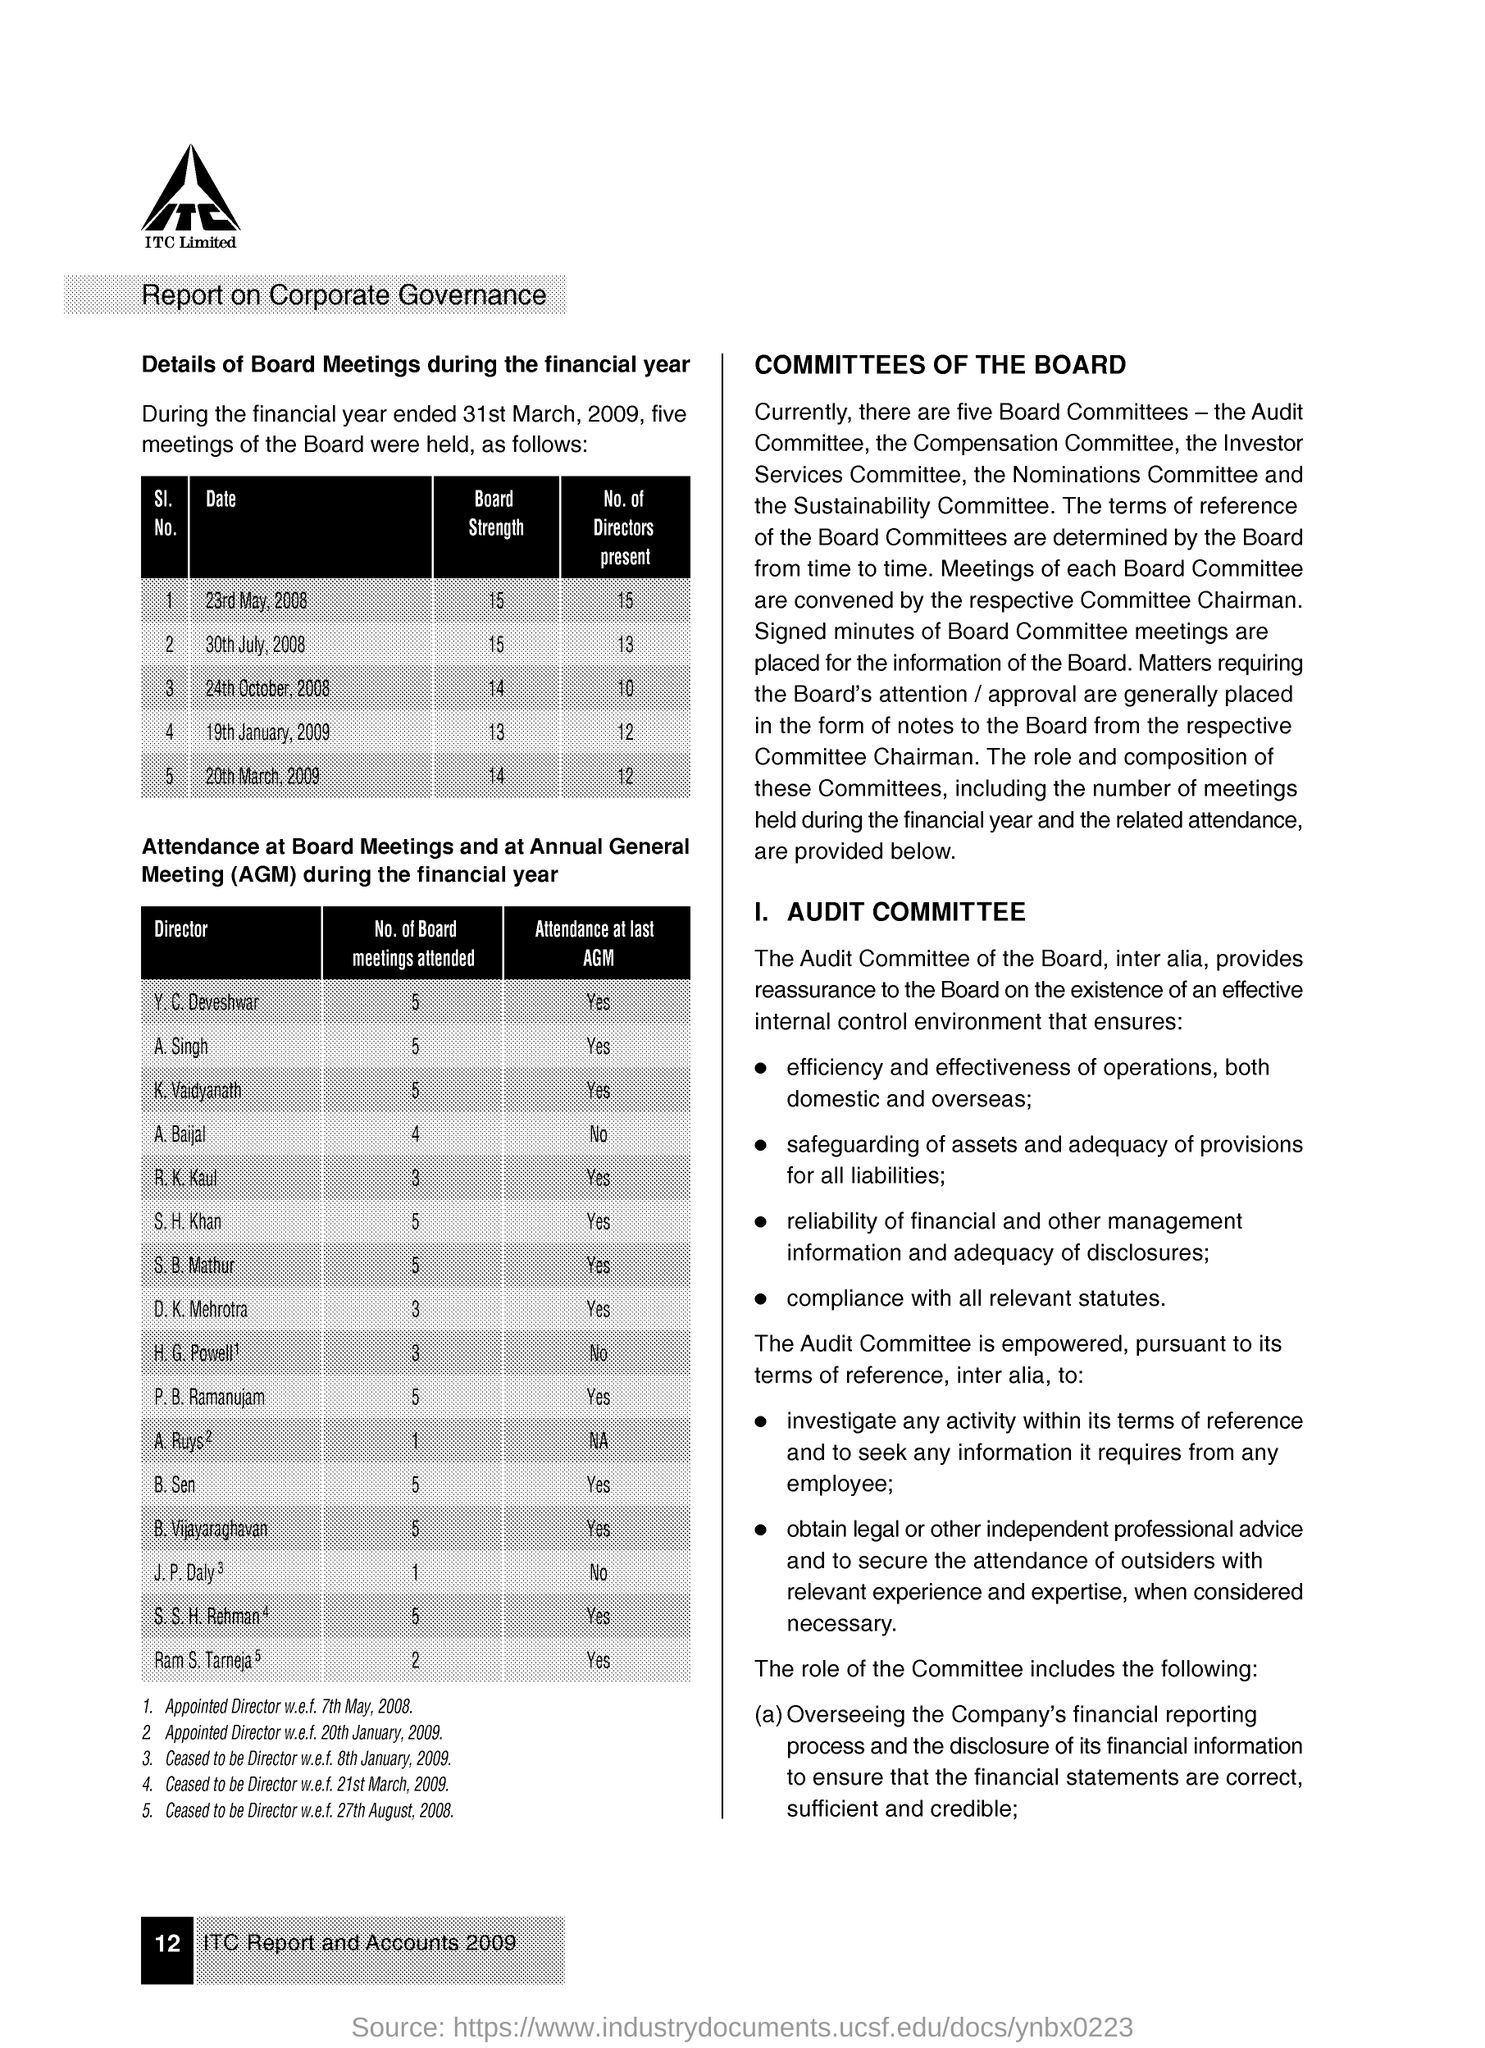Give some essential details in this illustration. During the financial year ended March 31, 2009, a total of five board meetings were held. On January 19, 2009, there were 12 directors present. 